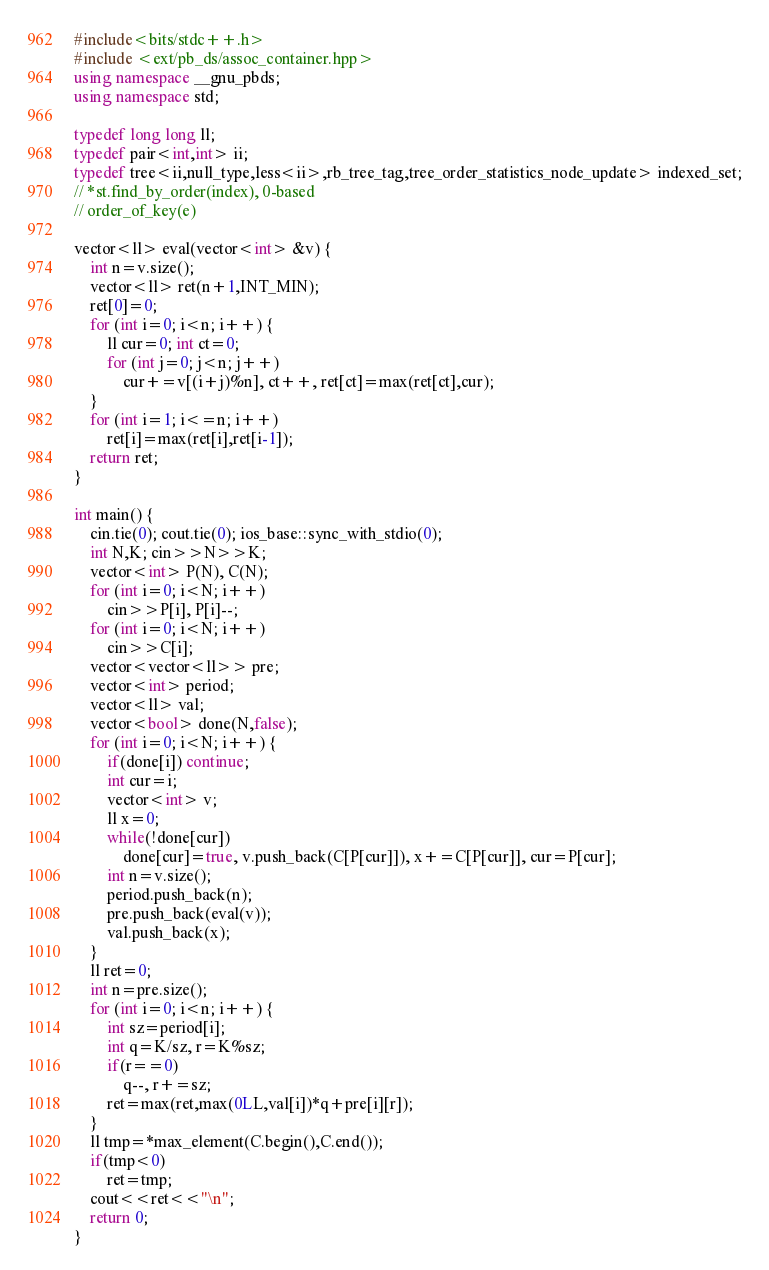Convert code to text. <code><loc_0><loc_0><loc_500><loc_500><_C++_>#include<bits/stdc++.h>
#include <ext/pb_ds/assoc_container.hpp>
using namespace __gnu_pbds;
using namespace std;

typedef long long ll;
typedef pair<int,int> ii;
typedef tree<ii,null_type,less<ii>,rb_tree_tag,tree_order_statistics_node_update> indexed_set;
// *st.find_by_order(index), 0-based
// order_of_key(e)

vector<ll> eval(vector<int> &v) {
	int n=v.size();
	vector<ll> ret(n+1,INT_MIN);
	ret[0]=0;
	for (int i=0; i<n; i++) {
		ll cur=0; int ct=0;
		for (int j=0; j<n; j++)
			cur+=v[(i+j)%n], ct++, ret[ct]=max(ret[ct],cur);
	}
	for (int i=1; i<=n; i++)
		ret[i]=max(ret[i],ret[i-1]);
	return ret;
}

int main() {
	cin.tie(0); cout.tie(0); ios_base::sync_with_stdio(0);
	int N,K; cin>>N>>K;
	vector<int> P(N), C(N);
	for (int i=0; i<N; i++)
		cin>>P[i], P[i]--;
	for (int i=0; i<N; i++)
		cin>>C[i];
	vector<vector<ll>> pre;
	vector<int> period;
	vector<ll> val;
	vector<bool> done(N,false);
	for (int i=0; i<N; i++) {
		if(done[i]) continue;
		int cur=i;
		vector<int> v;
		ll x=0;
		while(!done[cur])
			done[cur]=true, v.push_back(C[P[cur]]), x+=C[P[cur]], cur=P[cur];
		int n=v.size();
		period.push_back(n);
		pre.push_back(eval(v));
		val.push_back(x);
	}
	ll ret=0;
	int n=pre.size();
	for (int i=0; i<n; i++) {
		int sz=period[i];
		int q=K/sz, r=K%sz;
		if(r==0)
			q--, r+=sz;
		ret=max(ret,max(0LL,val[i])*q+pre[i][r]);
	}
	ll tmp=*max_element(C.begin(),C.end());
	if(tmp<0)
		ret=tmp;
	cout<<ret<<"\n";
	return 0;
}</code> 